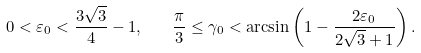<formula> <loc_0><loc_0><loc_500><loc_500>0 < \varepsilon _ { 0 } < \frac { 3 \sqrt { 3 } } { 4 } - 1 , \quad \frac { \pi } { 3 } \leq \gamma _ { 0 } < \arcsin \left ( 1 - \frac { 2 \varepsilon _ { 0 } } { 2 \sqrt { 3 } + 1 } \right ) .</formula> 